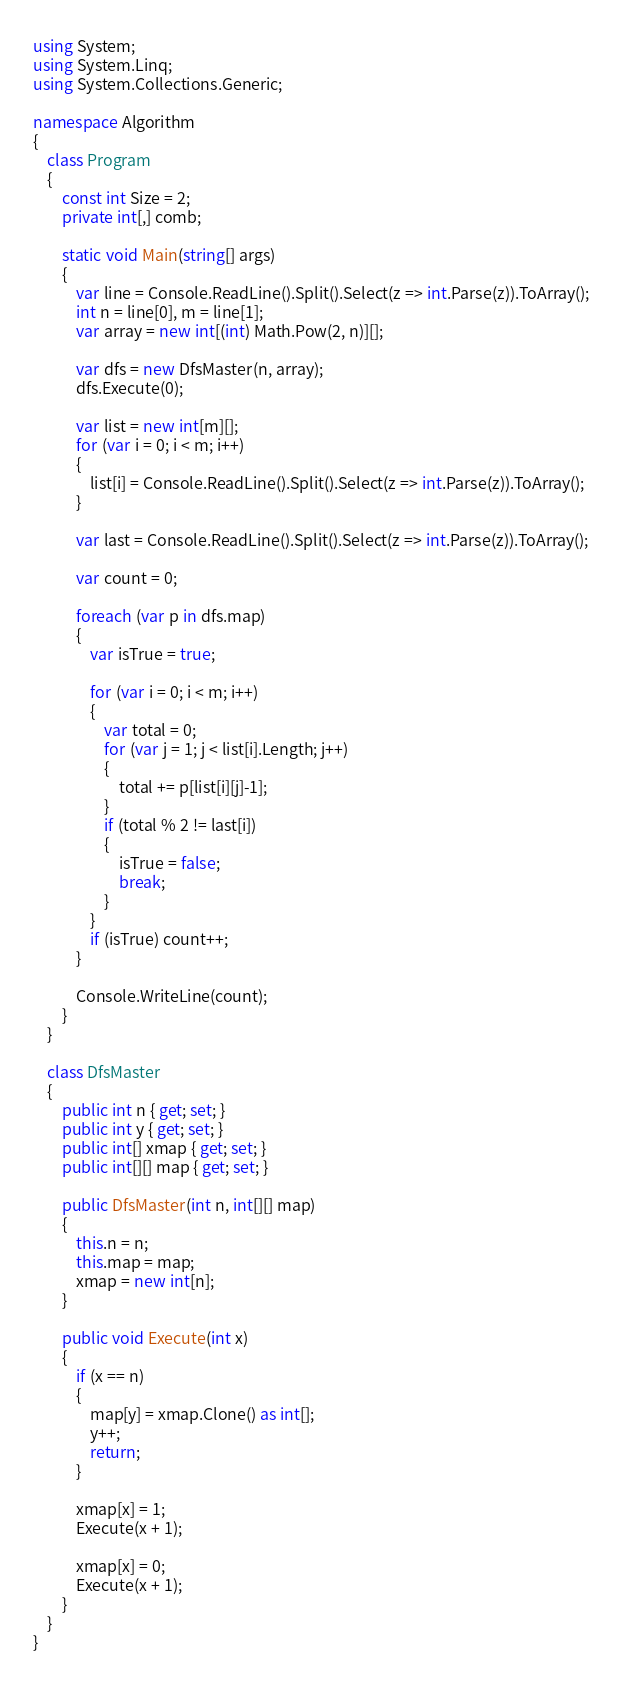<code> <loc_0><loc_0><loc_500><loc_500><_C#_>using System;
using System.Linq;
using System.Collections.Generic;

namespace Algorithm
{
    class Program
    {
        const int Size = 2;
        private int[,] comb;
        
        static void Main(string[] args)
        {
            var line = Console.ReadLine().Split().Select(z => int.Parse(z)).ToArray();
            int n = line[0], m = line[1];
            var array = new int[(int) Math.Pow(2, n)][];

            var dfs = new DfsMaster(n, array);
            dfs.Execute(0);

            var list = new int[m][];
            for (var i = 0; i < m; i++)
            {
                list[i] = Console.ReadLine().Split().Select(z => int.Parse(z)).ToArray();
            }

            var last = Console.ReadLine().Split().Select(z => int.Parse(z)).ToArray();

            var count = 0;

            foreach (var p in dfs.map)
            {
                var isTrue = true;

                for (var i = 0; i < m; i++)
                {
                    var total = 0;
                    for (var j = 1; j < list[i].Length; j++)
                    {
                        total += p[list[i][j]-1];
                    }
                    if (total % 2 != last[i])
                    {
                        isTrue = false;
                        break;
                    }
                }
                if (isTrue) count++;
            }

            Console.WriteLine(count);
        }
    }

    class DfsMaster
    {
        public int n { get; set; }
        public int y { get; set; }
        public int[] xmap { get; set; }
        public int[][] map { get; set; }

        public DfsMaster(int n, int[][] map)
        {
            this.n = n;
            this.map = map;
            xmap = new int[n];
        }

        public void Execute(int x)
        {
            if (x == n)
            {
                map[y] = xmap.Clone() as int[];
                y++;
                return;
            }

            xmap[x] = 1;
            Execute(x + 1);

            xmap[x] = 0;
            Execute(x + 1);
        }
    }
}</code> 